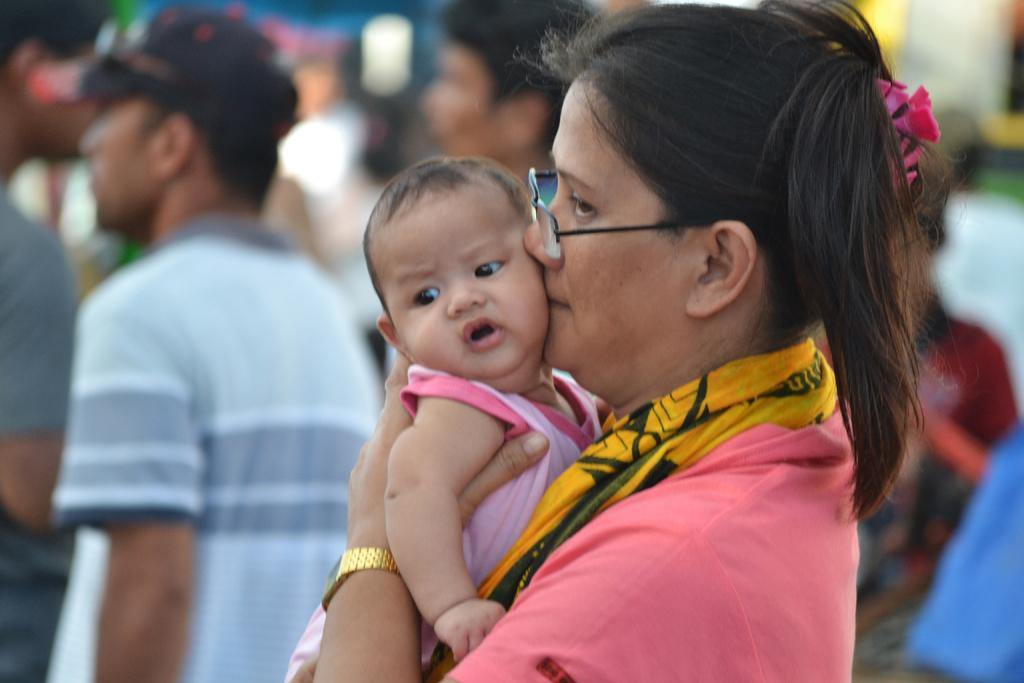Who is the main subject in the image? There is a lady in the center of the image. What is the lady wearing? The lady is wearing glasses. What is the lady doing in the image? The lady is holding a baby. Can you describe the people in the background of the image? There are other people standing in the background of the image. What type of plants can be seen growing on the level in the image? There is no mention of a level or plants in the image; it features a lady holding a baby and other people in the background. 